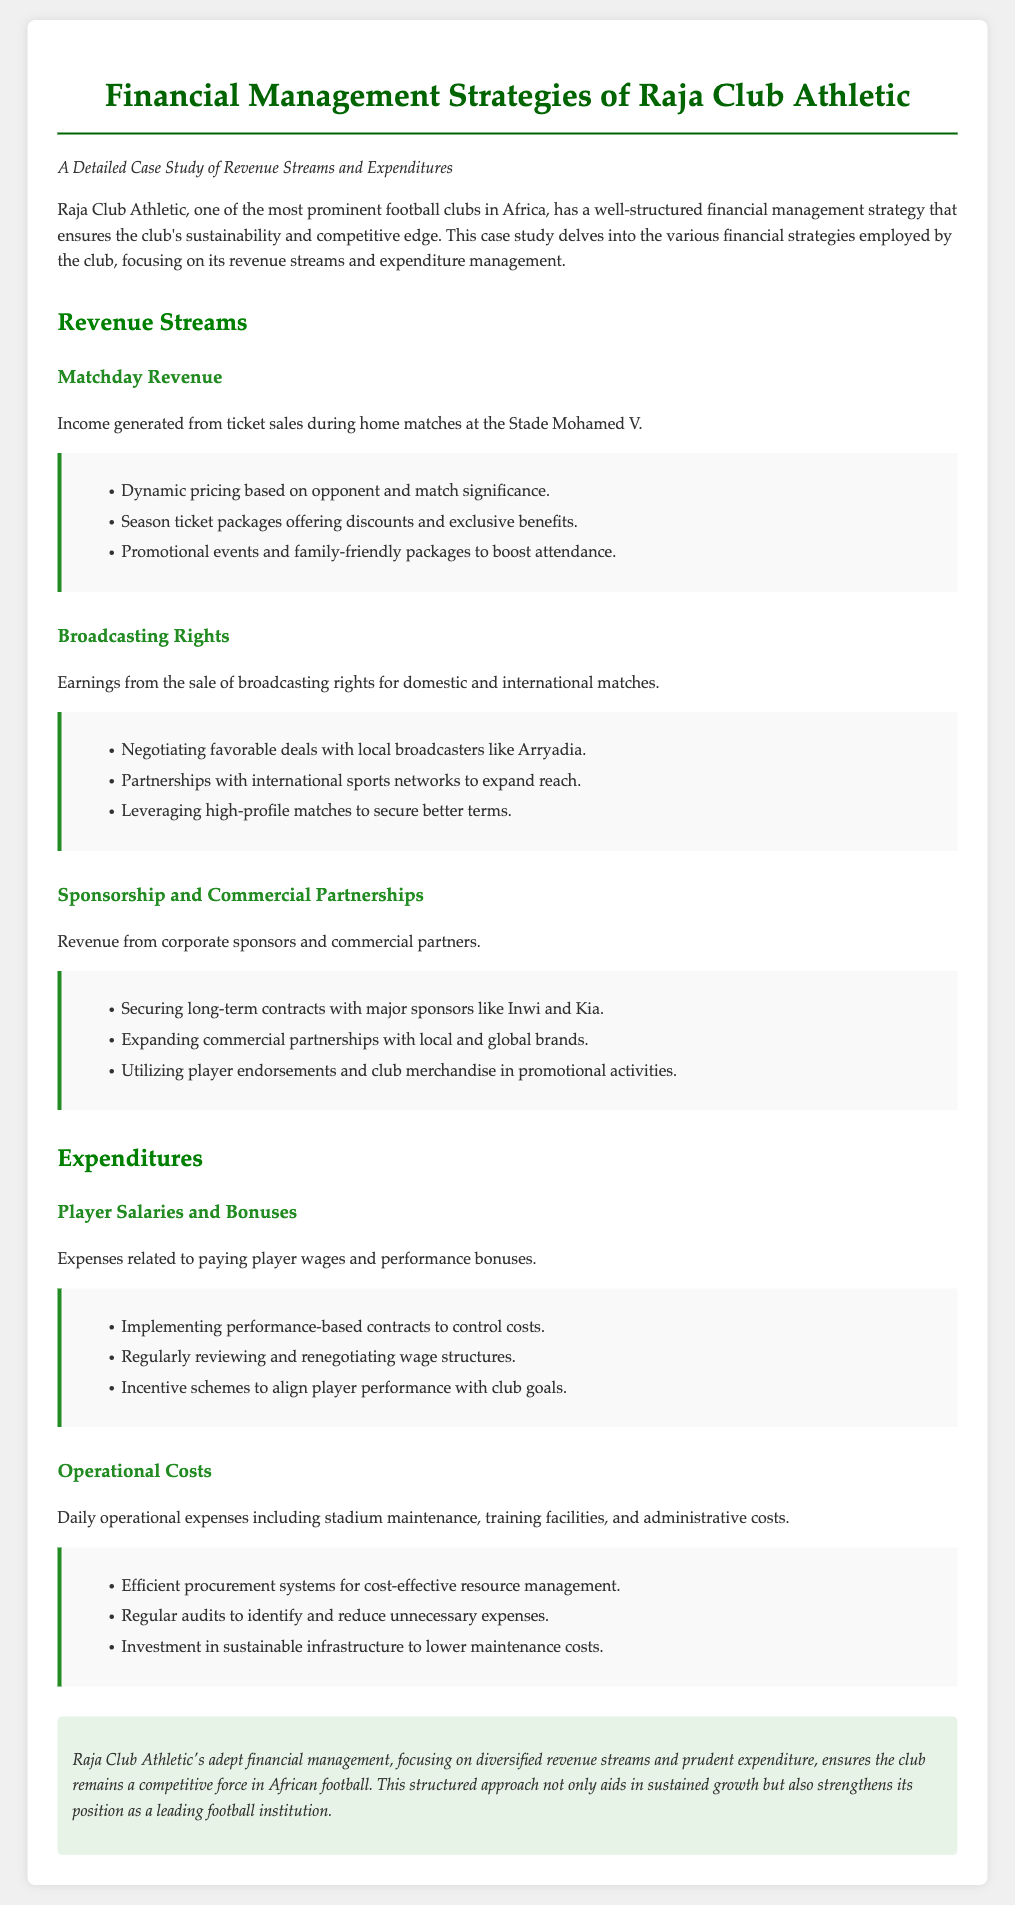What is the title of the document? The title provided at the top of the document is the name of the case study, which describes its focus on financial strategies.
Answer: Financial Management Strategies of Raja Club Athletic What is the primary venue for matchday revenue? The document states that matchday revenue is generated during home matches at a specific stadium.
Answer: Stade Mohamed V Who are two major sponsors mentioned in the text? The document lists key sponsors as part of the revenue from corporate sponsorships for Raja Club Athletic.
Answer: Inwi and Kia What strategy is mentioned for ticket pricing? The document refers to a specific approach to pricing tickets depending on various factors related to matches.
Answer: Dynamic pricing What expense is related to player wages? The document outlines a key expenditure category that includes salaries and bonuses given to players.
Answer: Player Salaries and Bonuses What is one method to manage operational costs? The document suggests a specific operational strategy aimed at reducing daily expenses for the club.
Answer: Efficient procurement systems What is the conclusion about Raja Club Athletic's financial management? The conclusion summarises the overall effectiveness and impact of the club's financial approaches as stated in the closing paragraph of the document.
Answer: Competitive force in African football Which area focuses on player performance rewards? The text highlights a category of expenses directly connected to incentivizing players based on their performance.
Answer: Player Salaries and Bonuses Name a revenue stream from media sources. The document specifies a source of income related to media rights for matches.
Answer: Broadcasting Rights 